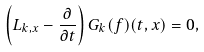Convert formula to latex. <formula><loc_0><loc_0><loc_500><loc_500>\left ( L _ { k , x } - \frac { \partial } { \partial t } \right ) G _ { k } ( f ) ( t , x ) = 0 ,</formula> 